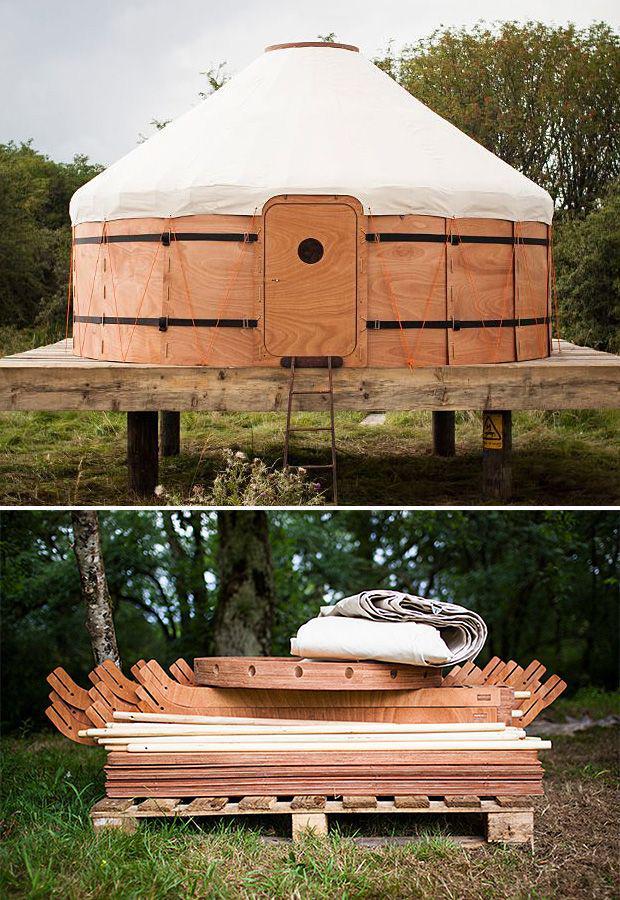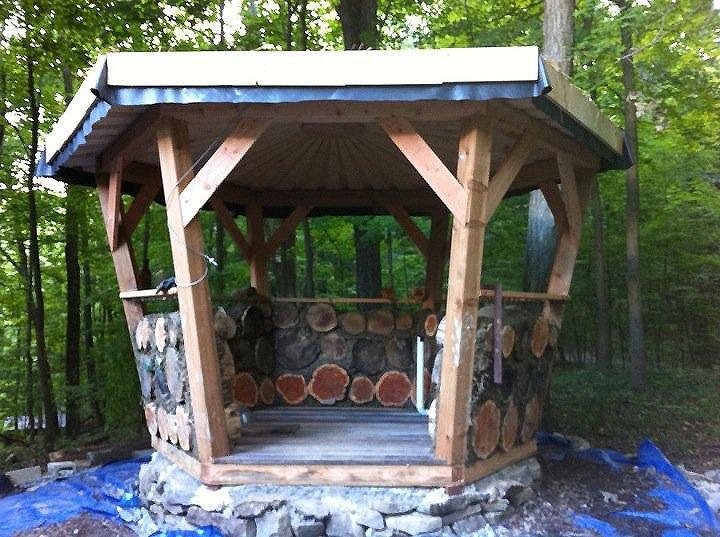The first image is the image on the left, the second image is the image on the right. Considering the images on both sides, is "The crosshatched pattern of the wood structure is clearly visible in at least one of the images." valid? Answer yes or no. No. 